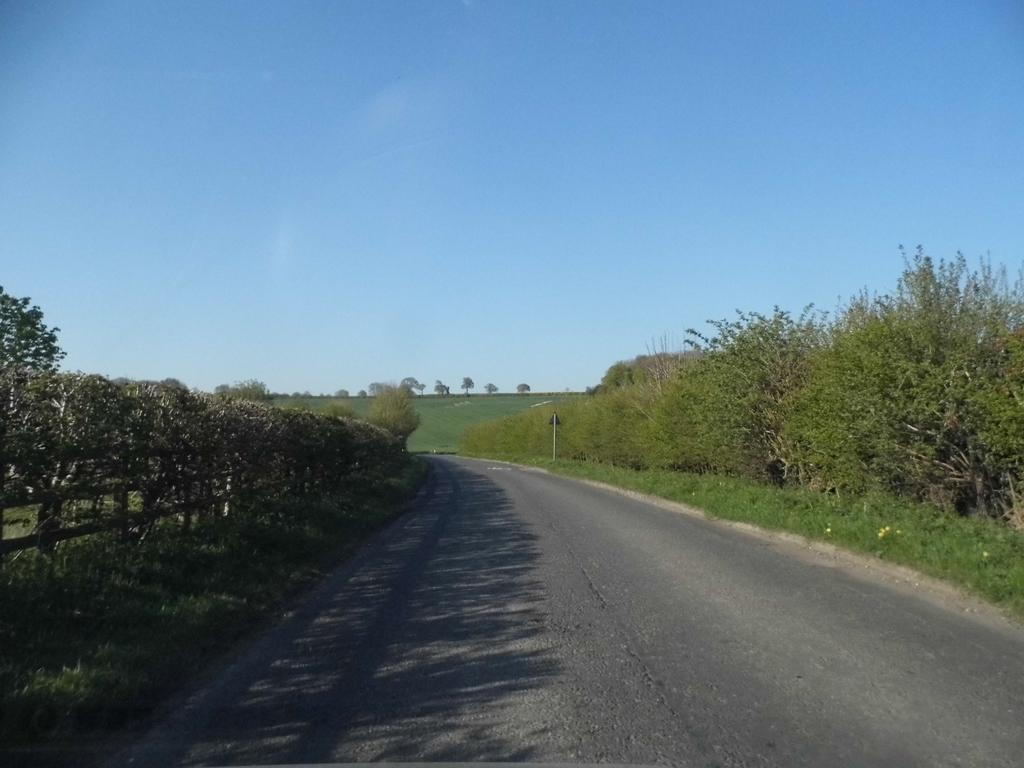What is the main feature of the image? There is a road in the image. What type of vegetation can be seen in the image? There are trees in the image. What is the ground surface like in the image? There is grass visible in the image. What is visible in the background of the image? The sky is visible in the background of the image. Can you see any friends eating rice and pickle in the image? There is no reference to friends, rice, or pickle in the image; it features a road, trees, grass, and the sky. 